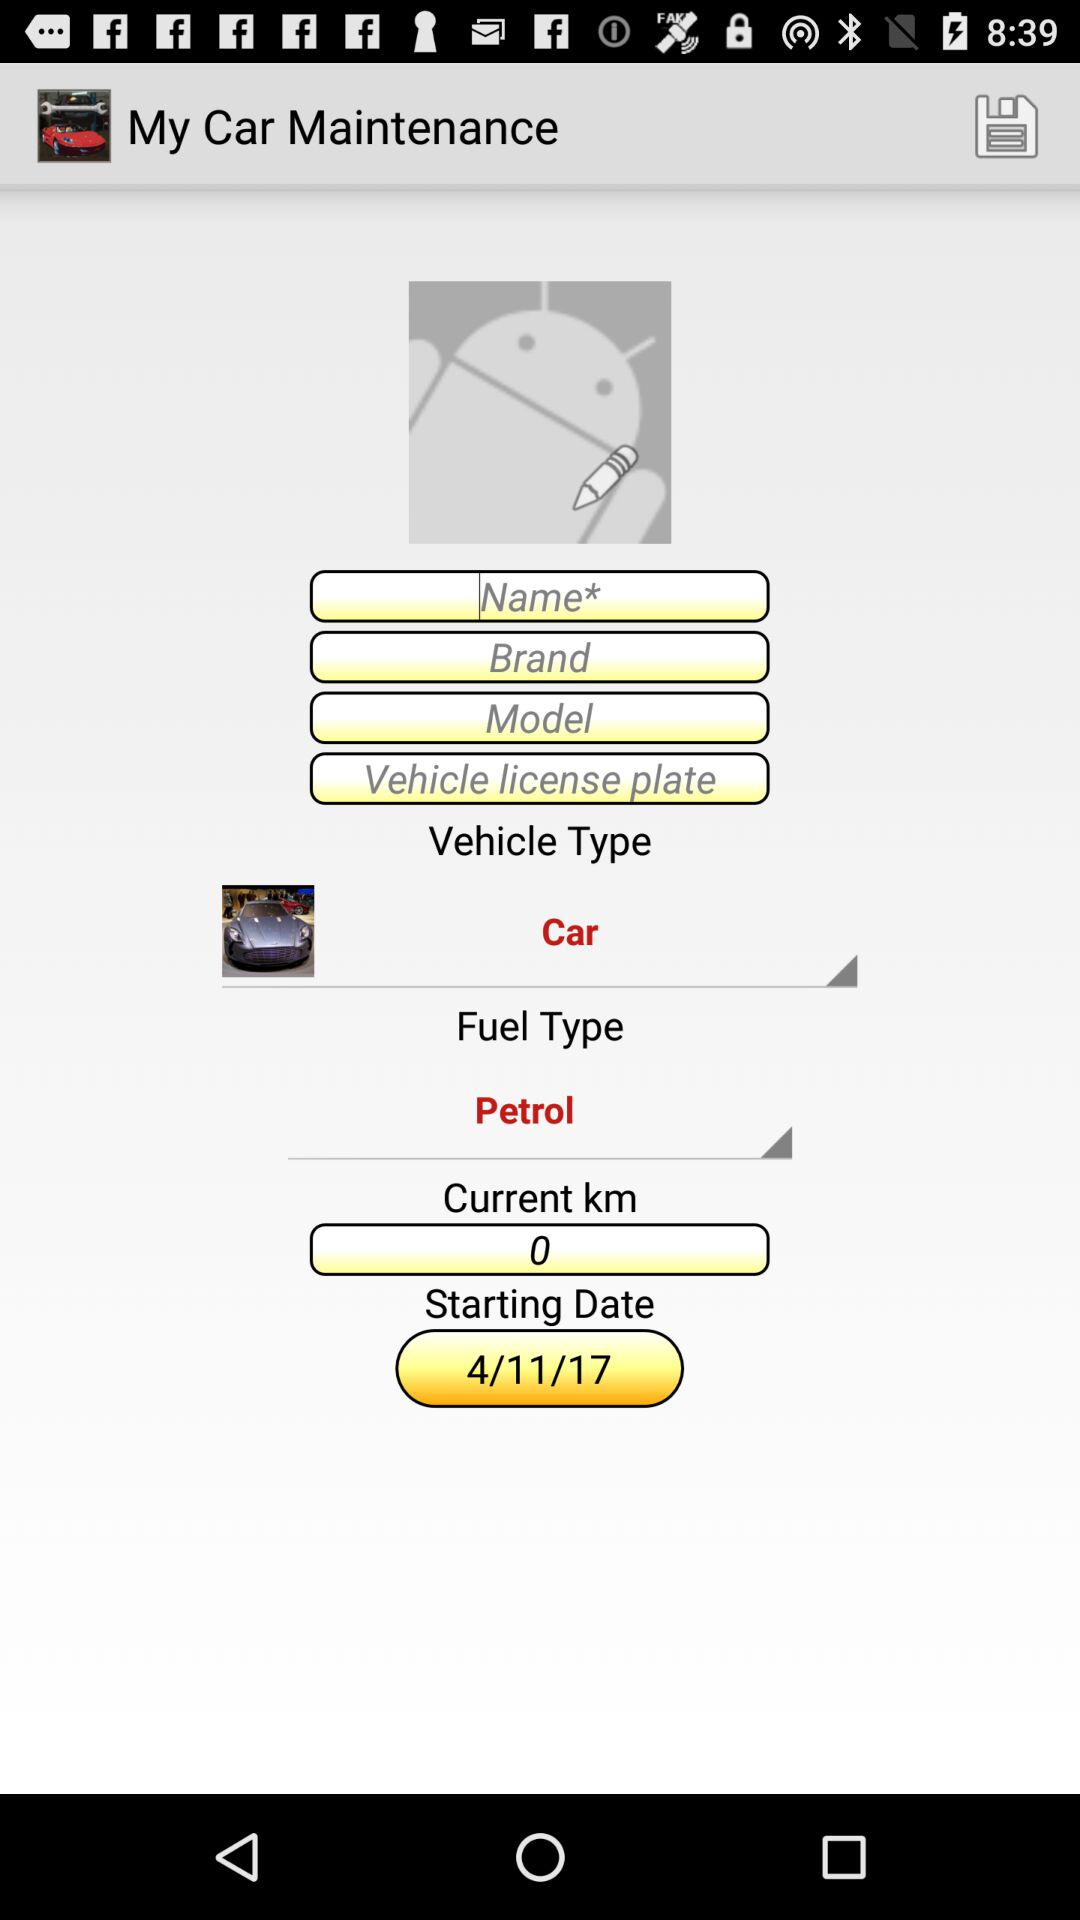What is the starting date? The starting date is November 4, 2017. 